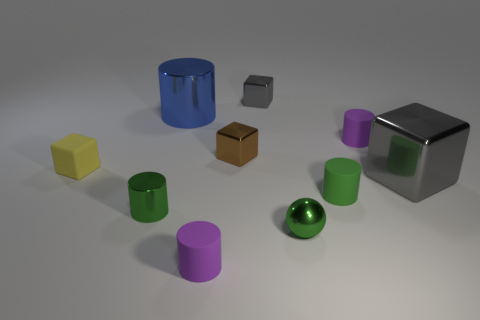What is the material of the tiny brown cube?
Offer a terse response. Metal. Do the ball to the right of the matte cube and the tiny brown metal block have the same size?
Your answer should be compact. Yes. Are there any other things that have the same size as the blue metal thing?
Provide a succinct answer. Yes. What is the size of the blue thing that is the same shape as the green matte thing?
Your answer should be very brief. Large. Are there an equal number of big blue things that are left of the large shiny cylinder and tiny green cylinders that are right of the green metallic cylinder?
Your response must be concise. No. What size is the gray cube that is in front of the big blue cylinder?
Provide a short and direct response. Large. Is the color of the big metal cylinder the same as the rubber block?
Give a very brief answer. No. Is there anything else that has the same shape as the green rubber thing?
Ensure brevity in your answer.  Yes. There is a small thing that is the same color as the big cube; what is it made of?
Your answer should be very brief. Metal. Are there an equal number of small purple things on the left side of the yellow rubber thing and purple things?
Keep it short and to the point. No. 